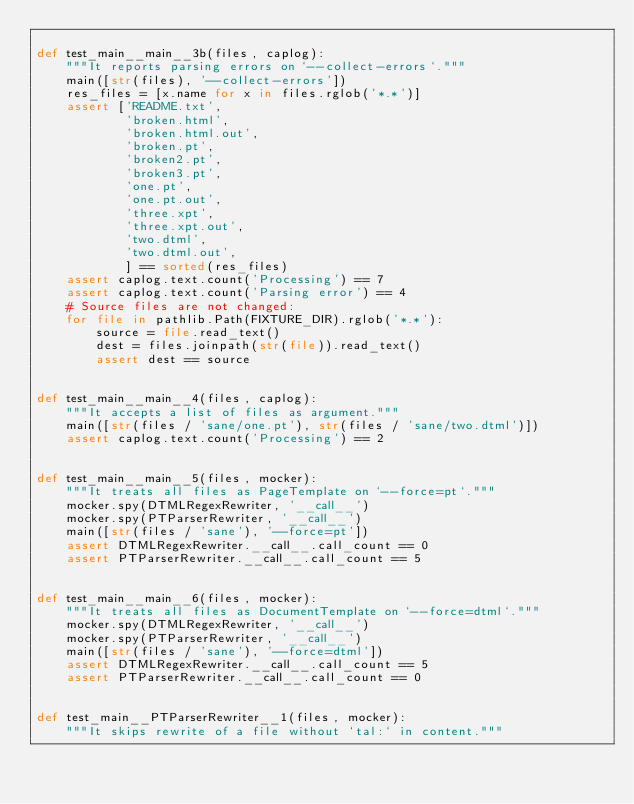<code> <loc_0><loc_0><loc_500><loc_500><_Python_>
def test_main__main__3b(files, caplog):
    """It reports parsing errors on `--collect-errors`."""
    main([str(files), '--collect-errors'])
    res_files = [x.name for x in files.rglob('*.*')]
    assert ['README.txt',
            'broken.html',
            'broken.html.out',
            'broken.pt',
            'broken2.pt',
            'broken3.pt',
            'one.pt',
            'one.pt.out',
            'three.xpt',
            'three.xpt.out',
            'two.dtml',
            'two.dtml.out',
            ] == sorted(res_files)
    assert caplog.text.count('Processing') == 7
    assert caplog.text.count('Parsing error') == 4
    # Source files are not changed:
    for file in pathlib.Path(FIXTURE_DIR).rglob('*.*'):
        source = file.read_text()
        dest = files.joinpath(str(file)).read_text()
        assert dest == source


def test_main__main__4(files, caplog):
    """It accepts a list of files as argument."""
    main([str(files / 'sane/one.pt'), str(files / 'sane/two.dtml')])
    assert caplog.text.count('Processing') == 2


def test_main__main__5(files, mocker):
    """It treats all files as PageTemplate on `--force=pt`."""
    mocker.spy(DTMLRegexRewriter, '__call__')
    mocker.spy(PTParserRewriter, '__call__')
    main([str(files / 'sane'), '--force=pt'])
    assert DTMLRegexRewriter.__call__.call_count == 0
    assert PTParserRewriter.__call__.call_count == 5


def test_main__main__6(files, mocker):
    """It treats all files as DocumentTemplate on `--force=dtml`."""
    mocker.spy(DTMLRegexRewriter, '__call__')
    mocker.spy(PTParserRewriter, '__call__')
    main([str(files / 'sane'), '--force=dtml'])
    assert DTMLRegexRewriter.__call__.call_count == 5
    assert PTParserRewriter.__call__.call_count == 0


def test_main__PTParserRewriter__1(files, mocker):
    """It skips rewrite of a file without `tal:` in content."""</code> 